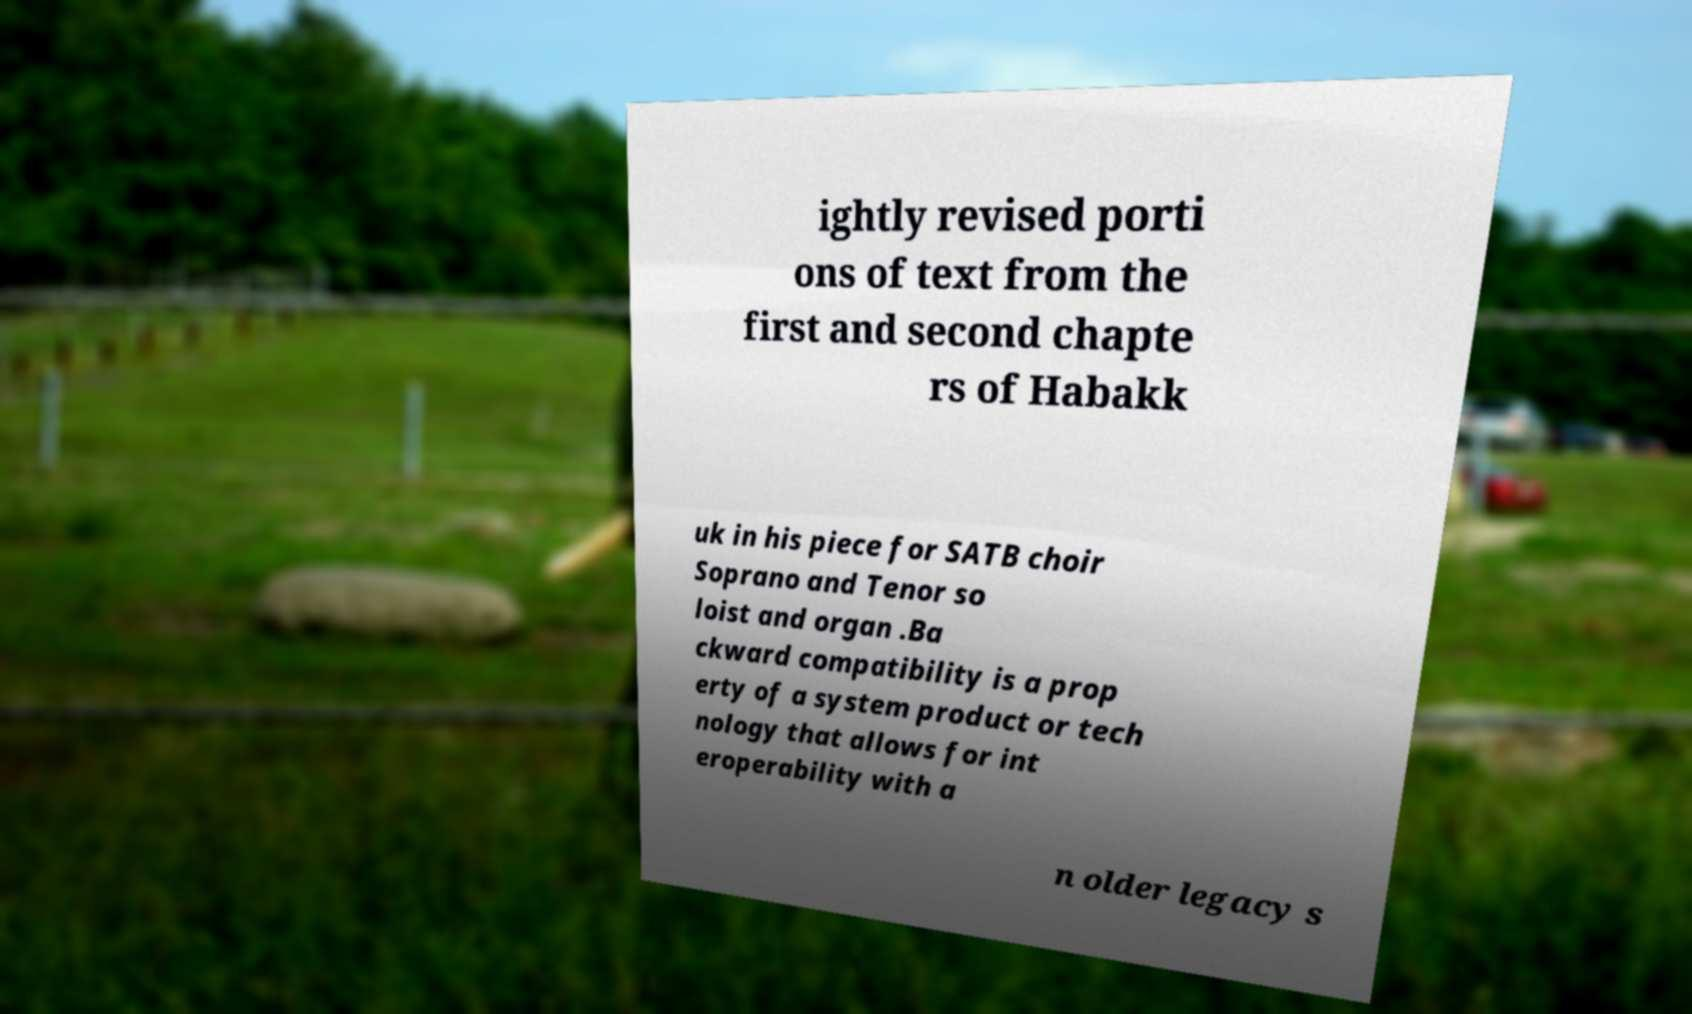Could you extract and type out the text from this image? ightly revised porti ons of text from the first and second chapte rs of Habakk uk in his piece for SATB choir Soprano and Tenor so loist and organ .Ba ckward compatibility is a prop erty of a system product or tech nology that allows for int eroperability with a n older legacy s 